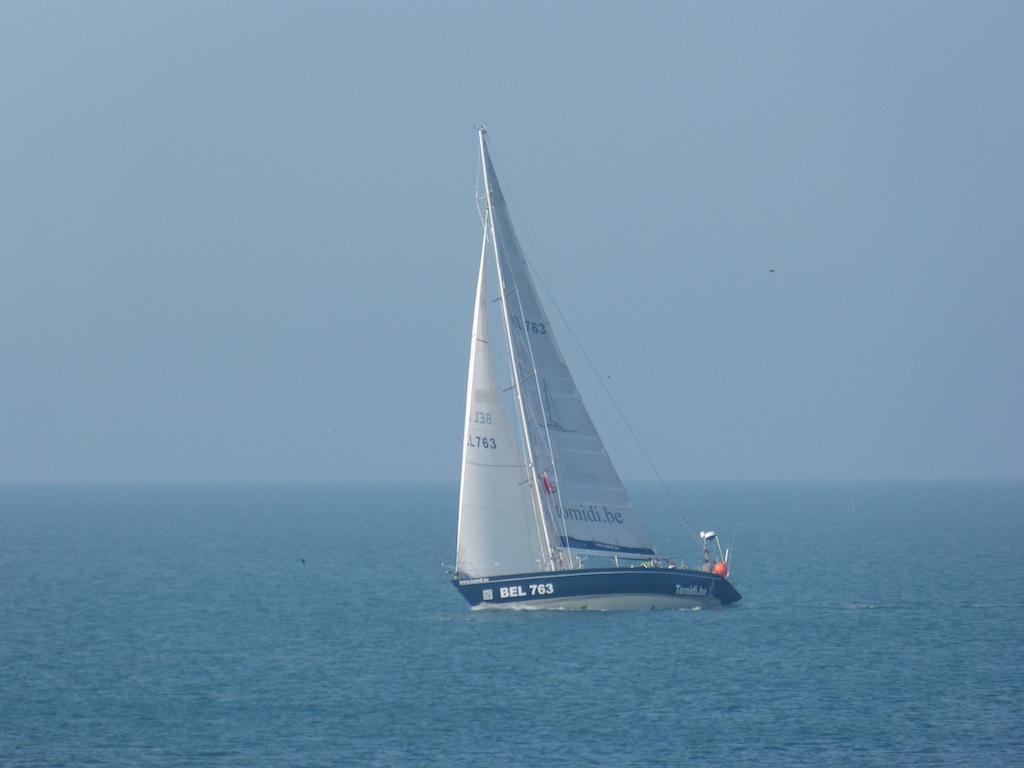Could you give a brief overview of what you see in this image? In the center of the image we can see a boat on the water. In the background there is sky. 